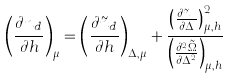Convert formula to latex. <formula><loc_0><loc_0><loc_500><loc_500>\left ( \frac { \partial n _ { d } } { \partial h } \right ) _ { \mu } = \left ( \frac { \partial \tilde { n } _ { d } } { \partial h } \right ) _ { \Delta , \mu } + \frac { \left ( \frac { \partial \tilde { n } _ { d } } { \partial \Delta } \right ) _ { \mu , h } ^ { 2 } } { \left ( \frac { \partial ^ { 2 } \tilde { \Omega } } { \partial \Delta ^ { 2 } } \right ) _ { \mu , h } }</formula> 